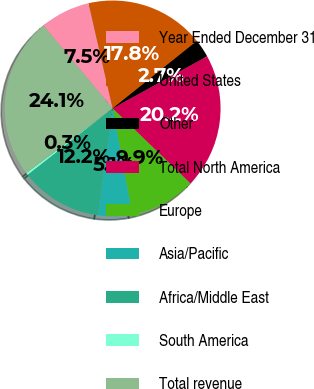Convert chart to OTSL. <chart><loc_0><loc_0><loc_500><loc_500><pie_chart><fcel>Year Ended December 31<fcel>United States<fcel>Other<fcel>Total North America<fcel>Europe<fcel>Asia/Pacific<fcel>Africa/Middle East<fcel>South America<fcel>Total revenue<nl><fcel>7.49%<fcel>17.84%<fcel>2.73%<fcel>20.22%<fcel>9.87%<fcel>5.11%<fcel>12.25%<fcel>0.35%<fcel>24.14%<nl></chart> 